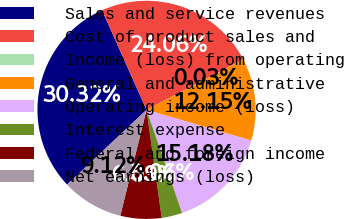<chart> <loc_0><loc_0><loc_500><loc_500><pie_chart><fcel>Sales and service revenues<fcel>Cost of product sales and<fcel>Income (loss) from operating<fcel>General and administrative<fcel>Operating income (loss)<fcel>Interest expense<fcel>Federal and foreign income<fcel>Net earnings (loss)<nl><fcel>30.33%<fcel>24.06%<fcel>0.03%<fcel>12.15%<fcel>15.18%<fcel>3.06%<fcel>6.09%<fcel>9.12%<nl></chart> 